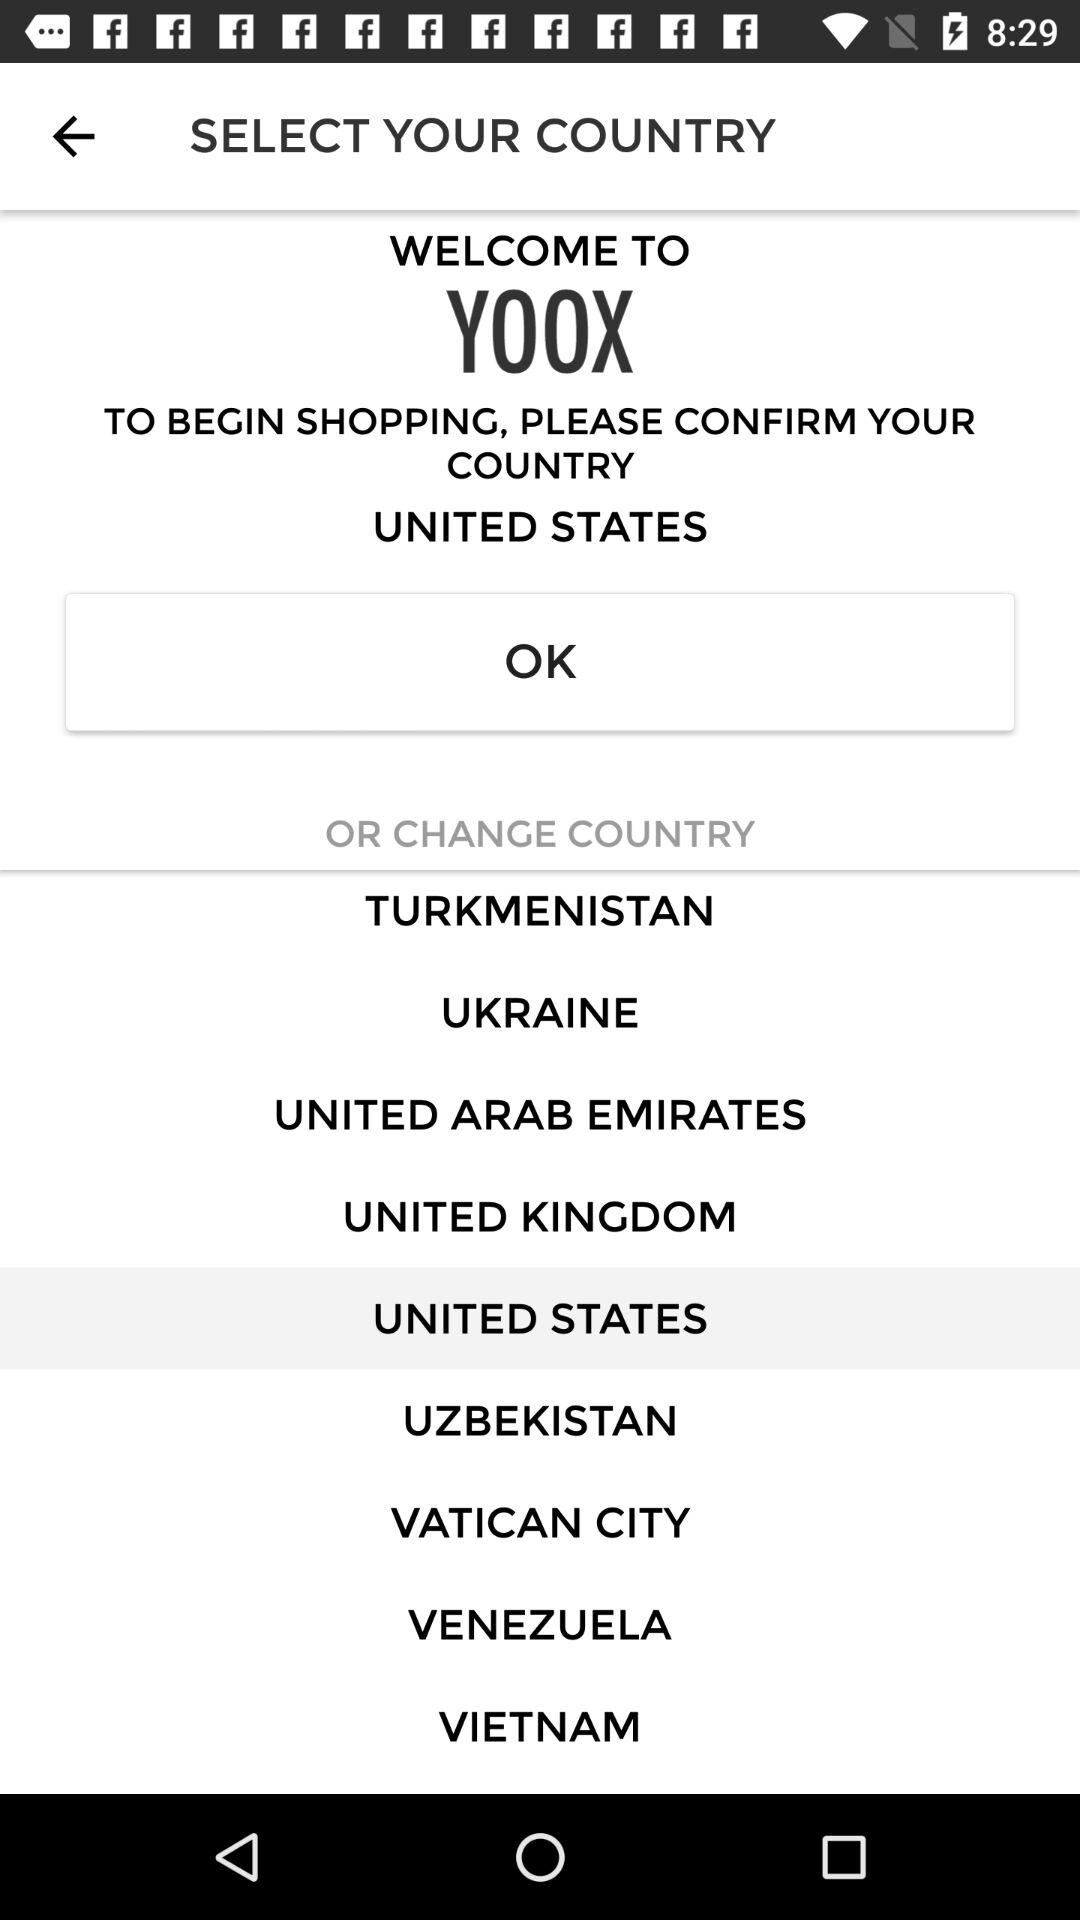What is the selected country? The selected country is "UNITED STATES". 